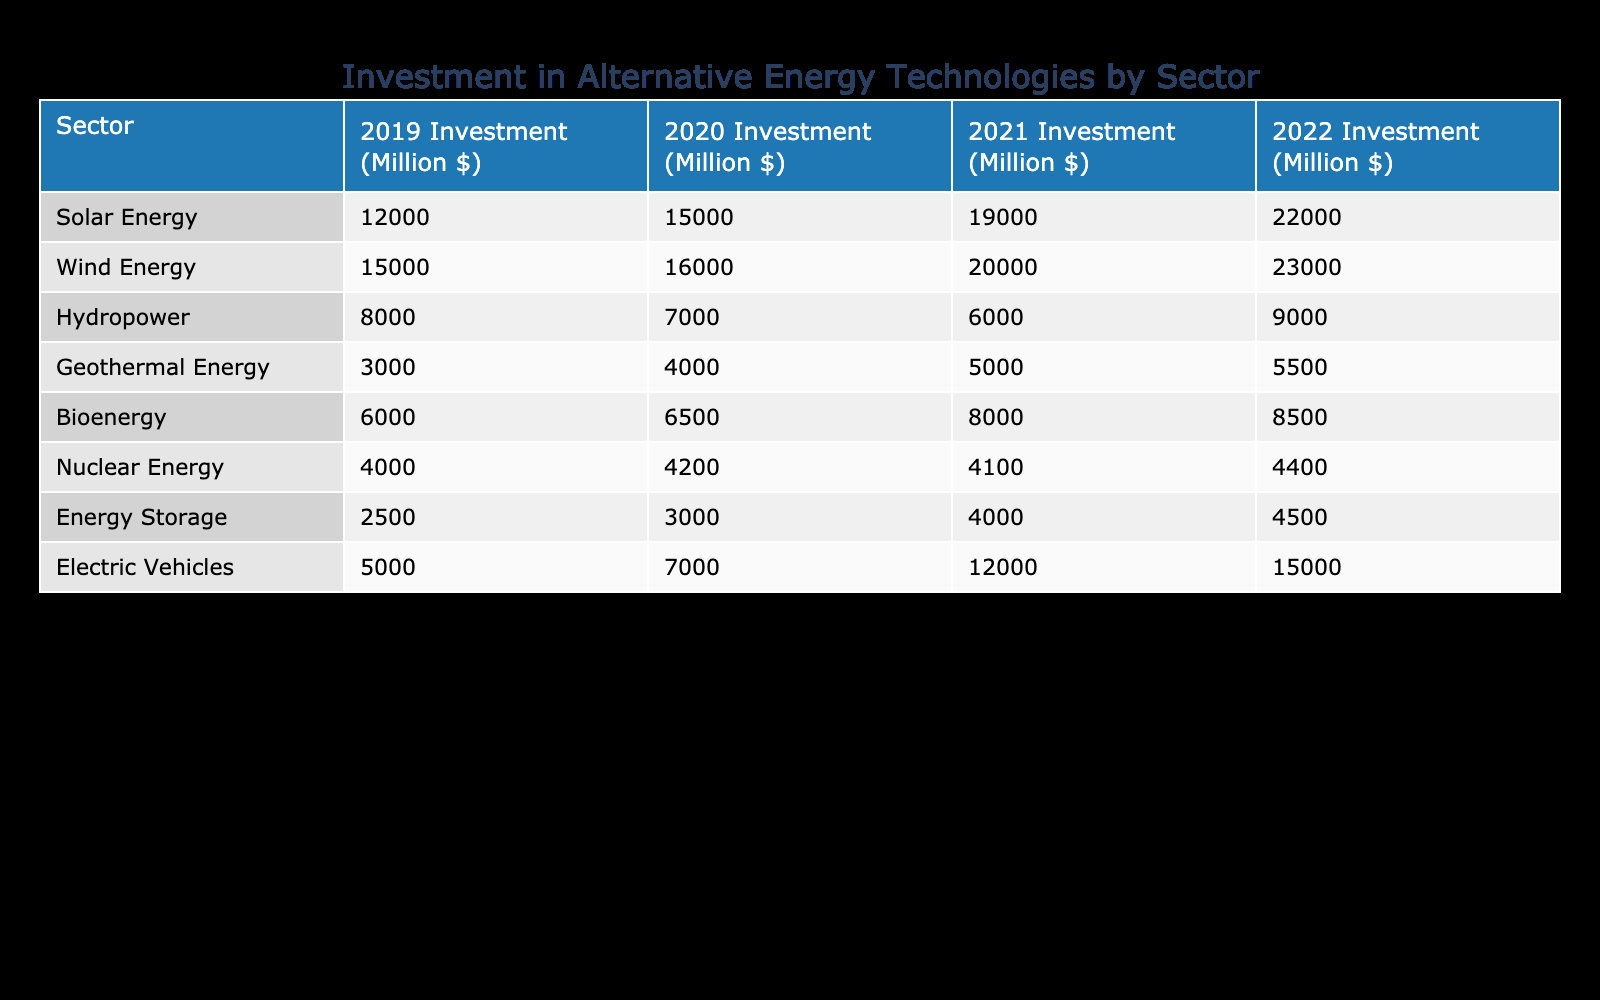What was the total investment in Solar Energy from 2019 to 2022? To find the total investment in Solar Energy, we need to sum the values from each year: 12000 + 15000 + 19000 + 22000 = 68000 million dollars.
Answer: 68000 million dollars Which sector had the highest investment in 2021? Looking at the investment amounts for 2021, Wind Energy had the highest investment at 20000 million dollars, compared to the other sectors.
Answer: Wind Energy Did the investment in Hydropower increase from 2021 to 2022? The investment in Hydropower for 2021 was 6000 million dollars and for 2022 it was 9000 million dollars. Since 9000 is greater than 6000, the investment did increase.
Answer: Yes What is the average investment in Geothermal Energy over the four years? To calculate the average investment for Geothermal Energy, we add up the yearly investments: 3000 + 4000 + 5000 + 5500 = 18000 million dollars. Then, to find the average, we divide this sum by the number of years (4): 18000 / 4 = 4500 million dollars.
Answer: 4500 million dollars Which sector shows the least investment over the four years? Analyzing the investment data, Geothermal Energy consistently shows the least investment, starting from 3000 million dollars in 2019 and reaching only up to 5500 million dollars in 2022.
Answer: Geothermal Energy Was the investment in Electric Vehicles higher in 2022 than in Wind Energy? Electric Vehicles had an investment of 15000 million dollars in 2022, while Wind Energy had 23000 million dollars. Since 15000 is less than 23000, the investment in Electric Vehicles was not higher.
Answer: No By how much did the investment in Energy Storage change from 2019 to 2022? The investment in Energy Storage for 2019 was 2500 million dollars and for 2022 it increased to 4500 million dollars. The change in investment is 4500 - 2500 = 2000 million dollars.
Answer: 2000 million dollars What percentage of the total investment in Bioenergy is represented by the 2022 investment? The total investment in Bioenergy from 2019 to 2022 is 6000 + 6500 + 8000 + 8500 = 29000 million dollars. The 2022 investment is 8500 million dollars. To find the percentage, we calculate (8500 / 29000) * 100 = approximately 29.31%.
Answer: Approximately 29.31% Which two sectors had the most similar investment in 2020? In 2020, the investments were: Wind Energy at 16000 million dollars and Electric Vehicles at 7000 million dollars. The differences between them are not minimal; hence analyzing closely, the two sectors with investments closest in value are Nuclear Energy at 4200 million dollars and Energy Storage at 3000 million dollars, which are relatively closer than others.
Answer: Nuclear Energy and Energy Storage 